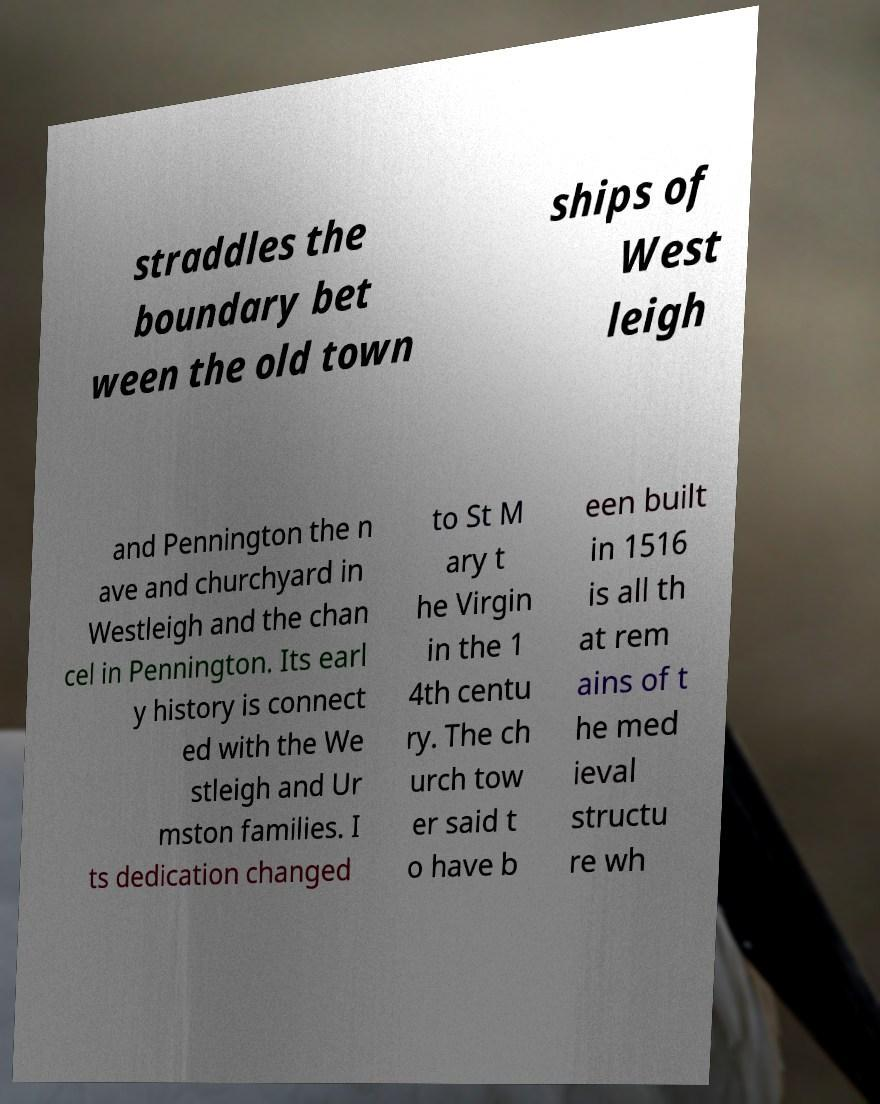What messages or text are displayed in this image? I need them in a readable, typed format. straddles the boundary bet ween the old town ships of West leigh and Pennington the n ave and churchyard in Westleigh and the chan cel in Pennington. Its earl y history is connect ed with the We stleigh and Ur mston families. I ts dedication changed to St M ary t he Virgin in the 1 4th centu ry. The ch urch tow er said t o have b een built in 1516 is all th at rem ains of t he med ieval structu re wh 